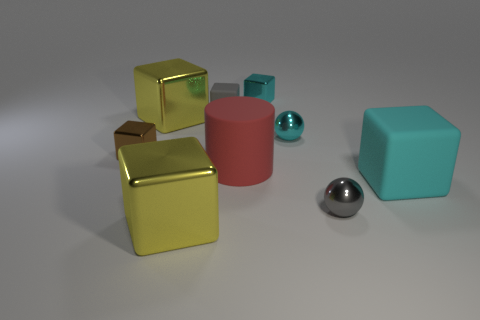Do the tiny brown shiny thing and the cyan rubber thing have the same shape?
Your answer should be compact. Yes. What is the shape of the big metal object that is right of the big metallic thing behind the brown cube?
Offer a terse response. Cube. Are any big cyan metal blocks visible?
Provide a short and direct response. No. There is a yellow object in front of the big yellow thing that is behind the large cyan matte object; how many cyan shiny balls are to the left of it?
Your response must be concise. 0. There is a brown shiny object; is its shape the same as the yellow object behind the small cyan sphere?
Ensure brevity in your answer.  Yes. Is the number of yellow objects greater than the number of metallic blocks?
Ensure brevity in your answer.  No. Is the shape of the big yellow metal thing in front of the large matte block the same as  the red matte thing?
Provide a succinct answer. No. Is the number of cyan things behind the small cyan shiny ball greater than the number of large green matte cylinders?
Offer a very short reply. Yes. What is the color of the small shiny object to the left of the large metal object that is in front of the tiny gray metallic object?
Your answer should be compact. Brown. What number of large gray things are there?
Offer a terse response. 0. 